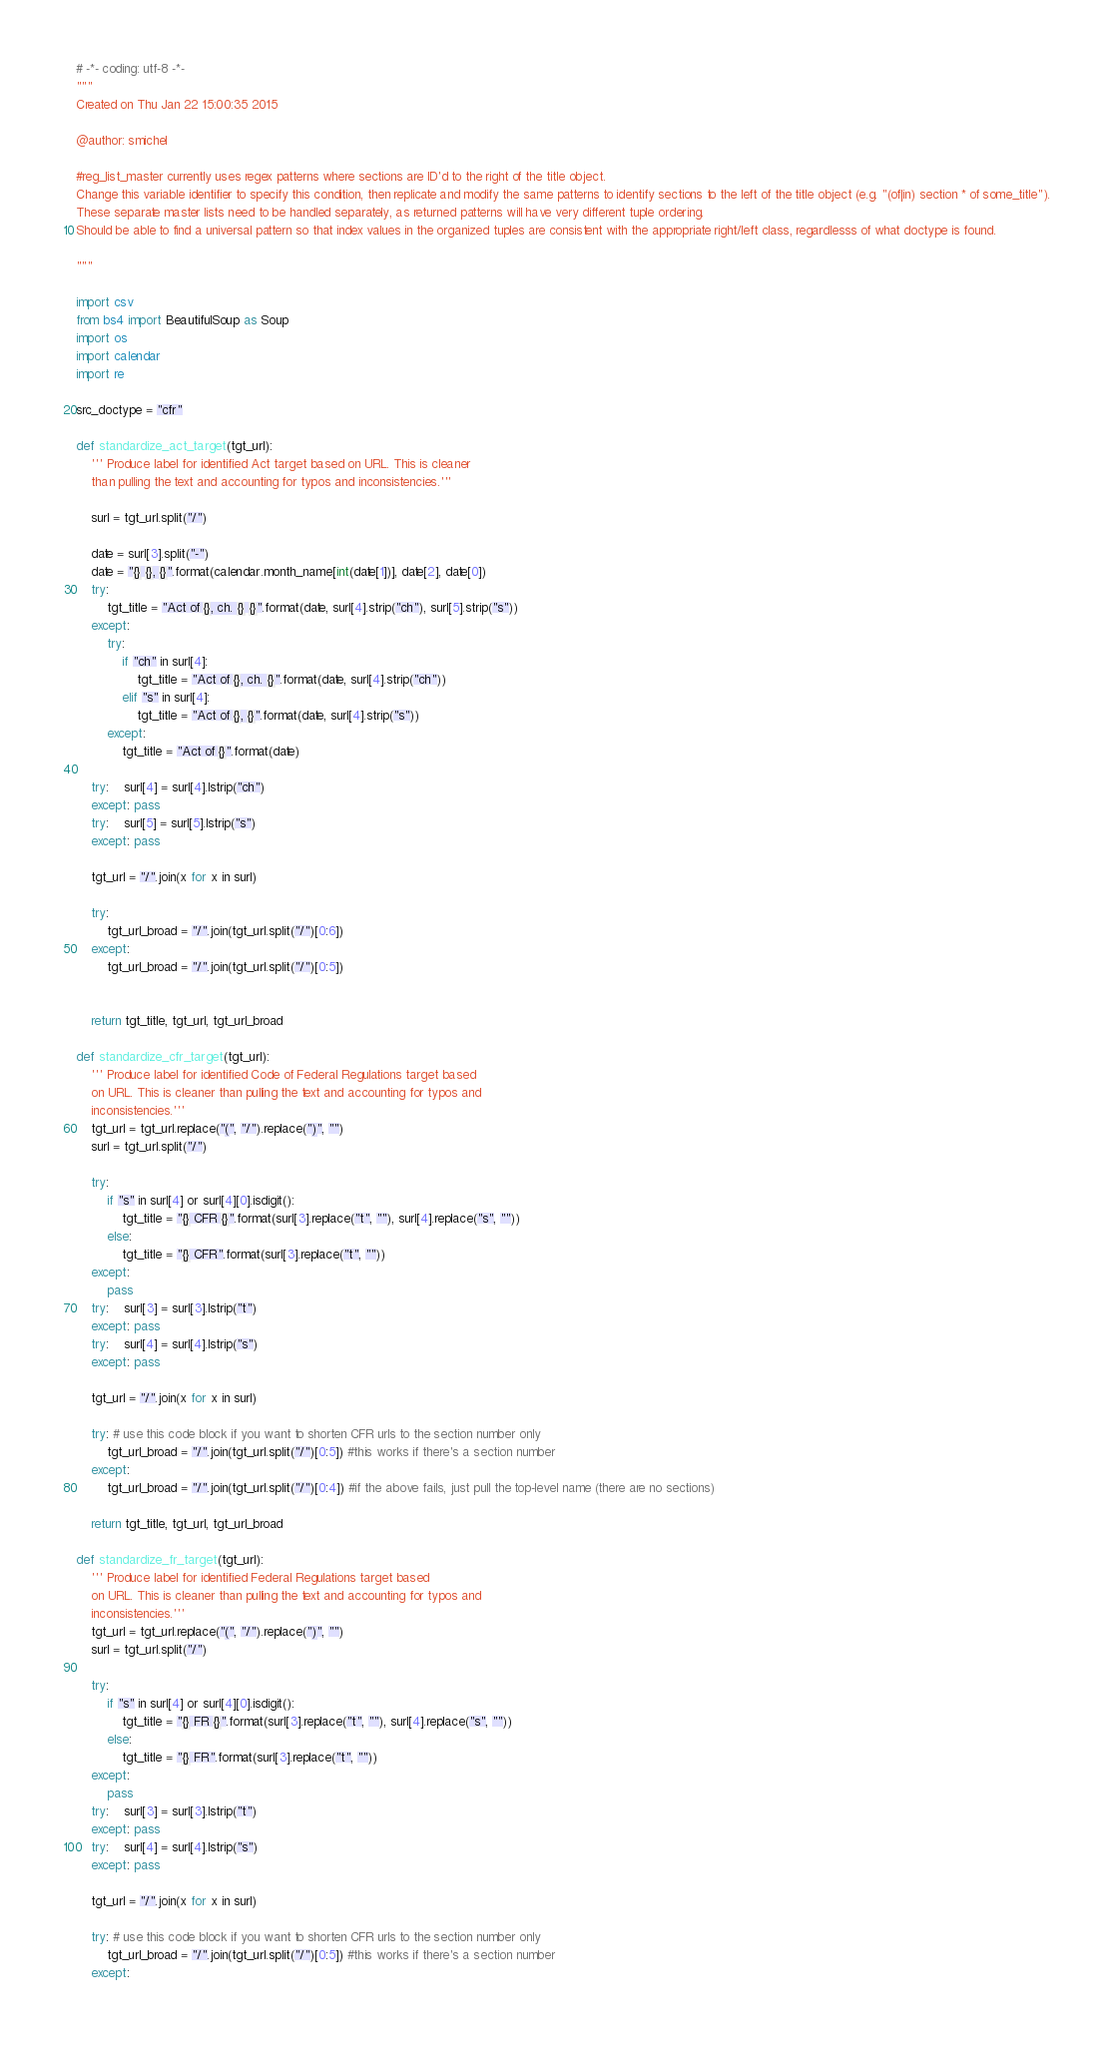Convert code to text. <code><loc_0><loc_0><loc_500><loc_500><_Python_># -*- coding: utf-8 -*-
"""
Created on Thu Jan 22 15:00:35 2015

@author: smichel

#reg_list_master currently uses regex patterns where sections are ID'd to the right of the title object. 
Change this variable identifier to specify this condition, then replicate and modify the same patterns to identify sections to the left of the title object (e.g. "(of|in) section * of some_title"). 
These separate master lists need to be handled separately, as returned patterns will have very different tuple ordering. 
Should be able to find a universal pattern so that index values in the organized tuples are consistent with the appropriate right/left class, regardlesss of what doctype is found. 

"""

import csv
from bs4 import BeautifulSoup as Soup
import os
import calendar
import re
    
src_doctype = "cfr"

def standardize_act_target(tgt_url): 
    ''' Produce label for identified Act target based on URL. This is cleaner 
    than pulling the text and accounting for typos and inconsistencies.'''

    surl = tgt_url.split("/")    
    
    date = surl[3].split("-")
    date = "{} {}, {}".format(calendar.month_name[int(date[1])], date[2], date[0])
    try:
        tgt_title = "Act of {}, ch. {} {}".format(date, surl[4].strip("ch"), surl[5].strip("s"))
    except:
        try:
            if "ch" in surl[4]:
                tgt_title = "Act of {}, ch. {}".format(date, surl[4].strip("ch"))
            elif "s" in surl[4]:
                tgt_title = "Act of {}, {}".format(date, surl[4].strip("s"))
        except: 
            tgt_title = "Act of {}".format(date)
            
    try:    surl[4] = surl[4].lstrip("ch")
    except: pass
    try:    surl[5] = surl[5].lstrip("s")
    except: pass

    tgt_url = "/".join(x for x in surl)

    try: 
        tgt_url_broad = "/".join(tgt_url.split("/")[0:6]) 
    except: 
        tgt_url_broad = "/".join(tgt_url.split("/")[0:5]) 

        
    return tgt_title, tgt_url, tgt_url_broad    
    
def standardize_cfr_target(tgt_url):
    ''' Produce label for identified Code of Federal Regulations target based 
    on URL. This is cleaner than pulling the text and accounting for typos and 
    inconsistencies.'''
    tgt_url = tgt_url.replace("(", "/").replace(")", "")
    surl = tgt_url.split("/")    

    try:
        if "s" in surl[4] or surl[4][0].isdigit():
            tgt_title = "{} CFR {}".format(surl[3].replace("t", ""), surl[4].replace("s", ""))
        else:
            tgt_title = "{} CFR".format(surl[3].replace("t", ""))
    except: 
        pass
    try:    surl[3] = surl[3].lstrip("t")
    except: pass
    try:    surl[4] = surl[4].lstrip("s")
    except: pass

    tgt_url = "/".join(x for x in surl)

    try: # use this code block if you want to shorten CFR urls to the section number only
        tgt_url_broad = "/".join(tgt_url.split("/")[0:5]) #this works if there's a section number
    except: 
        tgt_url_broad = "/".join(tgt_url.split("/")[0:4]) #if the above fails, just pull the top-level name (there are no sections)

    return tgt_title, tgt_url, tgt_url_broad

def standardize_fr_target(tgt_url):
    ''' Produce label for identified Federal Regulations target based 
    on URL. This is cleaner than pulling the text and accounting for typos and 
    inconsistencies.'''
    tgt_url = tgt_url.replace("(", "/").replace(")", "")
    surl = tgt_url.split("/")    

    try:
        if "s" in surl[4] or surl[4][0].isdigit():
            tgt_title = "{} FR {}".format(surl[3].replace("t", ""), surl[4].replace("s", ""))
        else:
            tgt_title = "{} FR".format(surl[3].replace("t", ""))
    except: 
        pass
    try:    surl[3] = surl[3].lstrip("t")
    except: pass
    try:    surl[4] = surl[4].lstrip("s")
    except: pass

    tgt_url = "/".join(x for x in surl)

    try: # use this code block if you want to shorten CFR urls to the section number only
        tgt_url_broad = "/".join(tgt_url.split("/")[0:5]) #this works if there's a section number
    except: </code> 